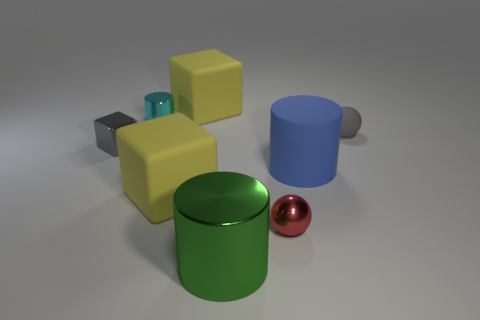Is the number of red metallic spheres that are behind the cyan object greater than the number of green metallic cylinders behind the red metal ball?
Your answer should be very brief. No. How many gray things are the same size as the red thing?
Your answer should be compact. 2. Are there fewer large blocks in front of the tiny red thing than metallic blocks in front of the big blue rubber thing?
Provide a succinct answer. No. Is there another small rubber object that has the same shape as the small rubber object?
Offer a terse response. No. Is the red object the same shape as the green shiny thing?
Provide a succinct answer. No. How many tiny things are cylinders or cyan metallic cylinders?
Your answer should be compact. 1. Is the number of big yellow matte cubes greater than the number of small blocks?
Your response must be concise. Yes. There is a green object that is made of the same material as the small red thing; what size is it?
Offer a terse response. Large. There is a yellow rubber cube behind the cyan metal cylinder; is it the same size as the cylinder that is right of the big green cylinder?
Your answer should be compact. Yes. How many objects are yellow objects that are in front of the blue cylinder or large cyan things?
Provide a short and direct response. 1. 